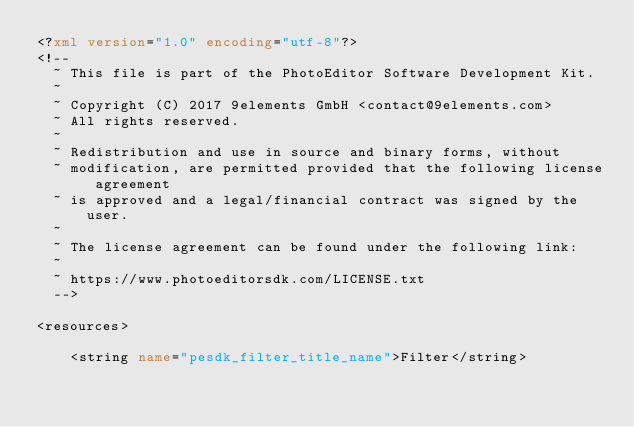<code> <loc_0><loc_0><loc_500><loc_500><_XML_><?xml version="1.0" encoding="utf-8"?>
<!--
  ~ This file is part of the PhotoEditor Software Development Kit.
  ~
  ~ Copyright (C) 2017 9elements GmbH <contact@9elements.com>
  ~ All rights reserved.
  ~
  ~ Redistribution and use in source and binary forms, without
  ~ modification, are permitted provided that the following license agreement
  ~ is approved and a legal/financial contract was signed by the user.
  ~
  ~ The license agreement can be found under the following link:
  ~
  ~ https://www.photoeditorsdk.com/LICENSE.txt
  -->

<resources>

    <string name="pesdk_filter_title_name">Filter</string></code> 